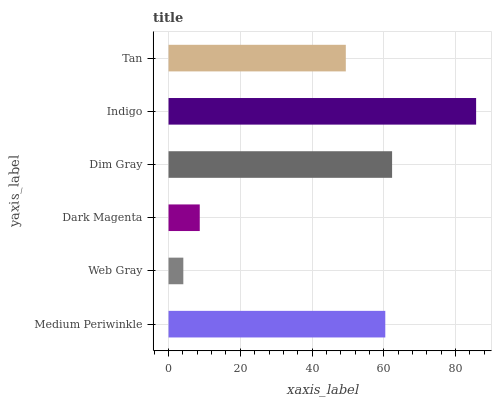Is Web Gray the minimum?
Answer yes or no. Yes. Is Indigo the maximum?
Answer yes or no. Yes. Is Dark Magenta the minimum?
Answer yes or no. No. Is Dark Magenta the maximum?
Answer yes or no. No. Is Dark Magenta greater than Web Gray?
Answer yes or no. Yes. Is Web Gray less than Dark Magenta?
Answer yes or no. Yes. Is Web Gray greater than Dark Magenta?
Answer yes or no. No. Is Dark Magenta less than Web Gray?
Answer yes or no. No. Is Medium Periwinkle the high median?
Answer yes or no. Yes. Is Tan the low median?
Answer yes or no. Yes. Is Dark Magenta the high median?
Answer yes or no. No. Is Dark Magenta the low median?
Answer yes or no. No. 